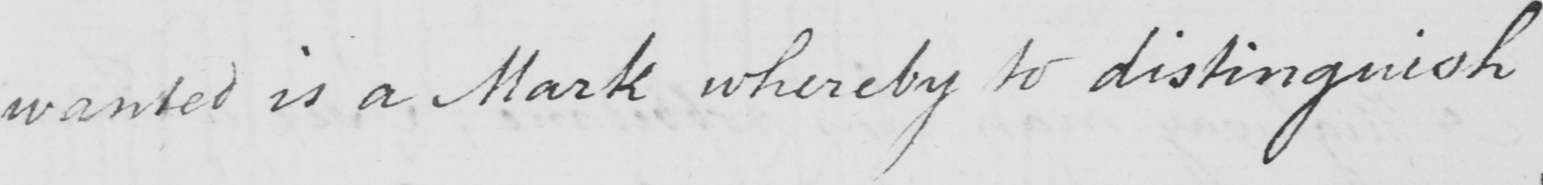Can you tell me what this handwritten text says? wanted is a Mark whereby to distinguish 